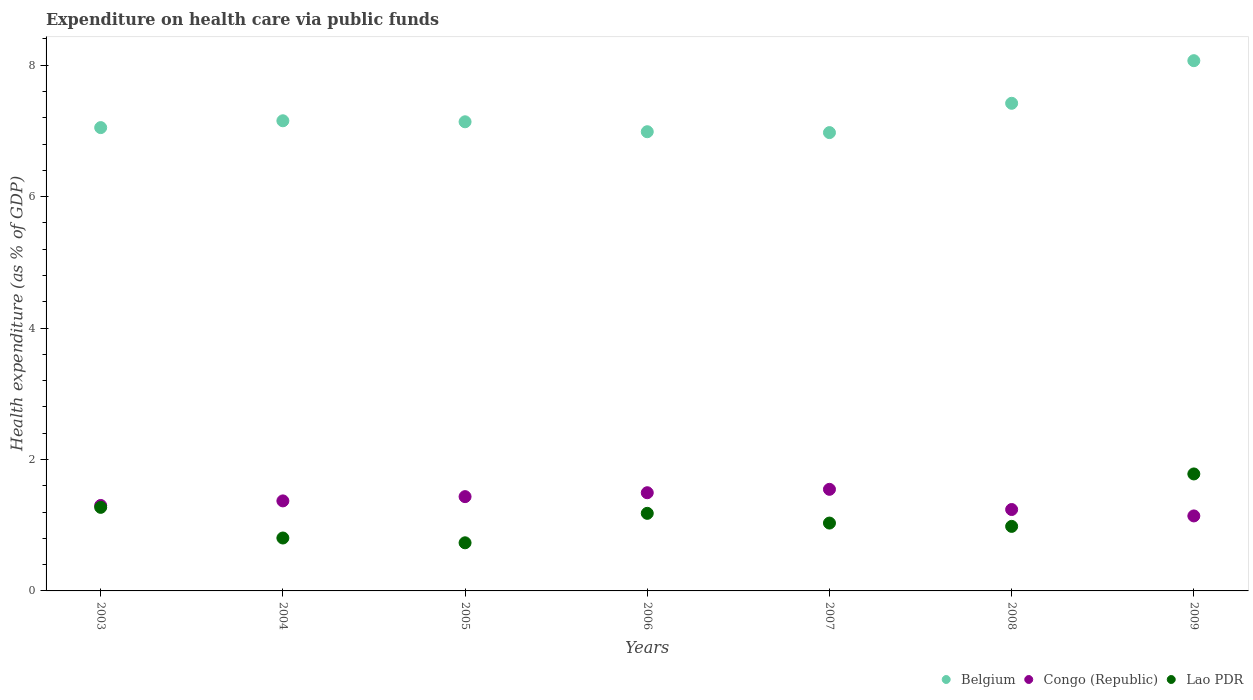How many different coloured dotlines are there?
Give a very brief answer. 3. Is the number of dotlines equal to the number of legend labels?
Your answer should be compact. Yes. What is the expenditure made on health care in Belgium in 2004?
Provide a succinct answer. 7.15. Across all years, what is the maximum expenditure made on health care in Congo (Republic)?
Your answer should be very brief. 1.55. Across all years, what is the minimum expenditure made on health care in Congo (Republic)?
Offer a terse response. 1.14. What is the total expenditure made on health care in Lao PDR in the graph?
Your answer should be compact. 7.78. What is the difference between the expenditure made on health care in Belgium in 2004 and that in 2008?
Offer a very short reply. -0.27. What is the difference between the expenditure made on health care in Congo (Republic) in 2004 and the expenditure made on health care in Lao PDR in 2005?
Offer a very short reply. 0.64. What is the average expenditure made on health care in Lao PDR per year?
Ensure brevity in your answer.  1.11. In the year 2008, what is the difference between the expenditure made on health care in Belgium and expenditure made on health care in Lao PDR?
Provide a short and direct response. 6.44. What is the ratio of the expenditure made on health care in Belgium in 2003 to that in 2006?
Offer a very short reply. 1.01. Is the difference between the expenditure made on health care in Belgium in 2005 and 2009 greater than the difference between the expenditure made on health care in Lao PDR in 2005 and 2009?
Ensure brevity in your answer.  Yes. What is the difference between the highest and the second highest expenditure made on health care in Congo (Republic)?
Ensure brevity in your answer.  0.05. What is the difference between the highest and the lowest expenditure made on health care in Lao PDR?
Provide a succinct answer. 1.05. In how many years, is the expenditure made on health care in Belgium greater than the average expenditure made on health care in Belgium taken over all years?
Provide a succinct answer. 2. Is the sum of the expenditure made on health care in Belgium in 2004 and 2009 greater than the maximum expenditure made on health care in Congo (Republic) across all years?
Ensure brevity in your answer.  Yes. Does the expenditure made on health care in Belgium monotonically increase over the years?
Keep it short and to the point. No. Is the expenditure made on health care in Lao PDR strictly greater than the expenditure made on health care in Belgium over the years?
Your answer should be very brief. No. How many years are there in the graph?
Your response must be concise. 7. What is the difference between two consecutive major ticks on the Y-axis?
Make the answer very short. 2. Where does the legend appear in the graph?
Provide a succinct answer. Bottom right. What is the title of the graph?
Your response must be concise. Expenditure on health care via public funds. What is the label or title of the Y-axis?
Your response must be concise. Health expenditure (as % of GDP). What is the Health expenditure (as % of GDP) in Belgium in 2003?
Ensure brevity in your answer.  7.05. What is the Health expenditure (as % of GDP) in Congo (Republic) in 2003?
Make the answer very short. 1.3. What is the Health expenditure (as % of GDP) of Lao PDR in 2003?
Give a very brief answer. 1.27. What is the Health expenditure (as % of GDP) of Belgium in 2004?
Your answer should be very brief. 7.15. What is the Health expenditure (as % of GDP) in Congo (Republic) in 2004?
Keep it short and to the point. 1.37. What is the Health expenditure (as % of GDP) of Lao PDR in 2004?
Ensure brevity in your answer.  0.81. What is the Health expenditure (as % of GDP) in Belgium in 2005?
Offer a terse response. 7.14. What is the Health expenditure (as % of GDP) of Congo (Republic) in 2005?
Offer a very short reply. 1.43. What is the Health expenditure (as % of GDP) in Lao PDR in 2005?
Offer a terse response. 0.73. What is the Health expenditure (as % of GDP) of Belgium in 2006?
Make the answer very short. 6.99. What is the Health expenditure (as % of GDP) of Congo (Republic) in 2006?
Provide a succinct answer. 1.49. What is the Health expenditure (as % of GDP) in Lao PDR in 2006?
Your response must be concise. 1.18. What is the Health expenditure (as % of GDP) in Belgium in 2007?
Make the answer very short. 6.97. What is the Health expenditure (as % of GDP) in Congo (Republic) in 2007?
Provide a short and direct response. 1.55. What is the Health expenditure (as % of GDP) of Lao PDR in 2007?
Offer a very short reply. 1.03. What is the Health expenditure (as % of GDP) of Belgium in 2008?
Make the answer very short. 7.42. What is the Health expenditure (as % of GDP) of Congo (Republic) in 2008?
Ensure brevity in your answer.  1.24. What is the Health expenditure (as % of GDP) in Lao PDR in 2008?
Your response must be concise. 0.98. What is the Health expenditure (as % of GDP) of Belgium in 2009?
Offer a very short reply. 8.07. What is the Health expenditure (as % of GDP) in Congo (Republic) in 2009?
Your response must be concise. 1.14. What is the Health expenditure (as % of GDP) of Lao PDR in 2009?
Provide a succinct answer. 1.78. Across all years, what is the maximum Health expenditure (as % of GDP) in Belgium?
Your answer should be compact. 8.07. Across all years, what is the maximum Health expenditure (as % of GDP) of Congo (Republic)?
Your response must be concise. 1.55. Across all years, what is the maximum Health expenditure (as % of GDP) of Lao PDR?
Make the answer very short. 1.78. Across all years, what is the minimum Health expenditure (as % of GDP) of Belgium?
Ensure brevity in your answer.  6.97. Across all years, what is the minimum Health expenditure (as % of GDP) in Congo (Republic)?
Provide a succinct answer. 1.14. Across all years, what is the minimum Health expenditure (as % of GDP) in Lao PDR?
Keep it short and to the point. 0.73. What is the total Health expenditure (as % of GDP) of Belgium in the graph?
Offer a terse response. 50.79. What is the total Health expenditure (as % of GDP) in Congo (Republic) in the graph?
Keep it short and to the point. 9.52. What is the total Health expenditure (as % of GDP) in Lao PDR in the graph?
Offer a terse response. 7.78. What is the difference between the Health expenditure (as % of GDP) of Belgium in 2003 and that in 2004?
Offer a terse response. -0.1. What is the difference between the Health expenditure (as % of GDP) in Congo (Republic) in 2003 and that in 2004?
Ensure brevity in your answer.  -0.07. What is the difference between the Health expenditure (as % of GDP) of Lao PDR in 2003 and that in 2004?
Make the answer very short. 0.47. What is the difference between the Health expenditure (as % of GDP) in Belgium in 2003 and that in 2005?
Your response must be concise. -0.09. What is the difference between the Health expenditure (as % of GDP) in Congo (Republic) in 2003 and that in 2005?
Provide a succinct answer. -0.13. What is the difference between the Health expenditure (as % of GDP) of Lao PDR in 2003 and that in 2005?
Give a very brief answer. 0.54. What is the difference between the Health expenditure (as % of GDP) in Belgium in 2003 and that in 2006?
Keep it short and to the point. 0.06. What is the difference between the Health expenditure (as % of GDP) in Congo (Republic) in 2003 and that in 2006?
Provide a short and direct response. -0.19. What is the difference between the Health expenditure (as % of GDP) in Lao PDR in 2003 and that in 2006?
Make the answer very short. 0.09. What is the difference between the Health expenditure (as % of GDP) of Belgium in 2003 and that in 2007?
Make the answer very short. 0.08. What is the difference between the Health expenditure (as % of GDP) of Congo (Republic) in 2003 and that in 2007?
Ensure brevity in your answer.  -0.25. What is the difference between the Health expenditure (as % of GDP) of Lao PDR in 2003 and that in 2007?
Give a very brief answer. 0.24. What is the difference between the Health expenditure (as % of GDP) in Belgium in 2003 and that in 2008?
Provide a succinct answer. -0.37. What is the difference between the Health expenditure (as % of GDP) of Congo (Republic) in 2003 and that in 2008?
Your answer should be compact. 0.06. What is the difference between the Health expenditure (as % of GDP) in Lao PDR in 2003 and that in 2008?
Your answer should be compact. 0.29. What is the difference between the Health expenditure (as % of GDP) of Belgium in 2003 and that in 2009?
Your answer should be compact. -1.02. What is the difference between the Health expenditure (as % of GDP) in Congo (Republic) in 2003 and that in 2009?
Keep it short and to the point. 0.16. What is the difference between the Health expenditure (as % of GDP) of Lao PDR in 2003 and that in 2009?
Provide a short and direct response. -0.51. What is the difference between the Health expenditure (as % of GDP) in Belgium in 2004 and that in 2005?
Your answer should be very brief. 0.02. What is the difference between the Health expenditure (as % of GDP) of Congo (Republic) in 2004 and that in 2005?
Your answer should be compact. -0.06. What is the difference between the Health expenditure (as % of GDP) in Lao PDR in 2004 and that in 2005?
Keep it short and to the point. 0.07. What is the difference between the Health expenditure (as % of GDP) of Belgium in 2004 and that in 2006?
Offer a terse response. 0.17. What is the difference between the Health expenditure (as % of GDP) of Congo (Republic) in 2004 and that in 2006?
Your answer should be compact. -0.12. What is the difference between the Health expenditure (as % of GDP) of Lao PDR in 2004 and that in 2006?
Give a very brief answer. -0.38. What is the difference between the Health expenditure (as % of GDP) of Belgium in 2004 and that in 2007?
Make the answer very short. 0.18. What is the difference between the Health expenditure (as % of GDP) of Congo (Republic) in 2004 and that in 2007?
Your answer should be very brief. -0.18. What is the difference between the Health expenditure (as % of GDP) of Lao PDR in 2004 and that in 2007?
Provide a succinct answer. -0.23. What is the difference between the Health expenditure (as % of GDP) in Belgium in 2004 and that in 2008?
Ensure brevity in your answer.  -0.27. What is the difference between the Health expenditure (as % of GDP) of Congo (Republic) in 2004 and that in 2008?
Provide a succinct answer. 0.13. What is the difference between the Health expenditure (as % of GDP) in Lao PDR in 2004 and that in 2008?
Make the answer very short. -0.18. What is the difference between the Health expenditure (as % of GDP) in Belgium in 2004 and that in 2009?
Provide a succinct answer. -0.91. What is the difference between the Health expenditure (as % of GDP) in Congo (Republic) in 2004 and that in 2009?
Give a very brief answer. 0.23. What is the difference between the Health expenditure (as % of GDP) of Lao PDR in 2004 and that in 2009?
Your answer should be compact. -0.97. What is the difference between the Health expenditure (as % of GDP) in Belgium in 2005 and that in 2006?
Offer a terse response. 0.15. What is the difference between the Health expenditure (as % of GDP) of Congo (Republic) in 2005 and that in 2006?
Your answer should be very brief. -0.06. What is the difference between the Health expenditure (as % of GDP) of Lao PDR in 2005 and that in 2006?
Offer a terse response. -0.45. What is the difference between the Health expenditure (as % of GDP) of Belgium in 2005 and that in 2007?
Provide a short and direct response. 0.16. What is the difference between the Health expenditure (as % of GDP) in Congo (Republic) in 2005 and that in 2007?
Provide a succinct answer. -0.11. What is the difference between the Health expenditure (as % of GDP) in Lao PDR in 2005 and that in 2007?
Give a very brief answer. -0.3. What is the difference between the Health expenditure (as % of GDP) in Belgium in 2005 and that in 2008?
Offer a very short reply. -0.28. What is the difference between the Health expenditure (as % of GDP) in Congo (Republic) in 2005 and that in 2008?
Ensure brevity in your answer.  0.2. What is the difference between the Health expenditure (as % of GDP) of Lao PDR in 2005 and that in 2008?
Your answer should be compact. -0.25. What is the difference between the Health expenditure (as % of GDP) in Belgium in 2005 and that in 2009?
Your answer should be compact. -0.93. What is the difference between the Health expenditure (as % of GDP) of Congo (Republic) in 2005 and that in 2009?
Make the answer very short. 0.29. What is the difference between the Health expenditure (as % of GDP) in Lao PDR in 2005 and that in 2009?
Make the answer very short. -1.05. What is the difference between the Health expenditure (as % of GDP) in Belgium in 2006 and that in 2007?
Ensure brevity in your answer.  0.01. What is the difference between the Health expenditure (as % of GDP) of Congo (Republic) in 2006 and that in 2007?
Offer a very short reply. -0.05. What is the difference between the Health expenditure (as % of GDP) of Lao PDR in 2006 and that in 2007?
Your response must be concise. 0.15. What is the difference between the Health expenditure (as % of GDP) of Belgium in 2006 and that in 2008?
Your answer should be very brief. -0.43. What is the difference between the Health expenditure (as % of GDP) in Congo (Republic) in 2006 and that in 2008?
Offer a very short reply. 0.26. What is the difference between the Health expenditure (as % of GDP) of Lao PDR in 2006 and that in 2008?
Make the answer very short. 0.2. What is the difference between the Health expenditure (as % of GDP) in Belgium in 2006 and that in 2009?
Keep it short and to the point. -1.08. What is the difference between the Health expenditure (as % of GDP) in Congo (Republic) in 2006 and that in 2009?
Give a very brief answer. 0.35. What is the difference between the Health expenditure (as % of GDP) in Lao PDR in 2006 and that in 2009?
Give a very brief answer. -0.6. What is the difference between the Health expenditure (as % of GDP) of Belgium in 2007 and that in 2008?
Your answer should be very brief. -0.45. What is the difference between the Health expenditure (as % of GDP) in Congo (Republic) in 2007 and that in 2008?
Your answer should be compact. 0.31. What is the difference between the Health expenditure (as % of GDP) of Lao PDR in 2007 and that in 2008?
Provide a short and direct response. 0.05. What is the difference between the Health expenditure (as % of GDP) in Belgium in 2007 and that in 2009?
Your response must be concise. -1.09. What is the difference between the Health expenditure (as % of GDP) in Congo (Republic) in 2007 and that in 2009?
Provide a short and direct response. 0.4. What is the difference between the Health expenditure (as % of GDP) of Lao PDR in 2007 and that in 2009?
Your answer should be very brief. -0.75. What is the difference between the Health expenditure (as % of GDP) of Belgium in 2008 and that in 2009?
Provide a short and direct response. -0.65. What is the difference between the Health expenditure (as % of GDP) in Congo (Republic) in 2008 and that in 2009?
Keep it short and to the point. 0.1. What is the difference between the Health expenditure (as % of GDP) in Lao PDR in 2008 and that in 2009?
Give a very brief answer. -0.8. What is the difference between the Health expenditure (as % of GDP) of Belgium in 2003 and the Health expenditure (as % of GDP) of Congo (Republic) in 2004?
Provide a succinct answer. 5.68. What is the difference between the Health expenditure (as % of GDP) of Belgium in 2003 and the Health expenditure (as % of GDP) of Lao PDR in 2004?
Provide a succinct answer. 6.24. What is the difference between the Health expenditure (as % of GDP) in Congo (Republic) in 2003 and the Health expenditure (as % of GDP) in Lao PDR in 2004?
Make the answer very short. 0.49. What is the difference between the Health expenditure (as % of GDP) of Belgium in 2003 and the Health expenditure (as % of GDP) of Congo (Republic) in 2005?
Offer a very short reply. 5.62. What is the difference between the Health expenditure (as % of GDP) in Belgium in 2003 and the Health expenditure (as % of GDP) in Lao PDR in 2005?
Your answer should be very brief. 6.32. What is the difference between the Health expenditure (as % of GDP) of Congo (Republic) in 2003 and the Health expenditure (as % of GDP) of Lao PDR in 2005?
Provide a succinct answer. 0.57. What is the difference between the Health expenditure (as % of GDP) of Belgium in 2003 and the Health expenditure (as % of GDP) of Congo (Republic) in 2006?
Offer a terse response. 5.56. What is the difference between the Health expenditure (as % of GDP) in Belgium in 2003 and the Health expenditure (as % of GDP) in Lao PDR in 2006?
Provide a short and direct response. 5.87. What is the difference between the Health expenditure (as % of GDP) of Congo (Republic) in 2003 and the Health expenditure (as % of GDP) of Lao PDR in 2006?
Your response must be concise. 0.12. What is the difference between the Health expenditure (as % of GDP) of Belgium in 2003 and the Health expenditure (as % of GDP) of Congo (Republic) in 2007?
Make the answer very short. 5.5. What is the difference between the Health expenditure (as % of GDP) in Belgium in 2003 and the Health expenditure (as % of GDP) in Lao PDR in 2007?
Offer a very short reply. 6.02. What is the difference between the Health expenditure (as % of GDP) of Congo (Republic) in 2003 and the Health expenditure (as % of GDP) of Lao PDR in 2007?
Give a very brief answer. 0.27. What is the difference between the Health expenditure (as % of GDP) in Belgium in 2003 and the Health expenditure (as % of GDP) in Congo (Republic) in 2008?
Keep it short and to the point. 5.81. What is the difference between the Health expenditure (as % of GDP) in Belgium in 2003 and the Health expenditure (as % of GDP) in Lao PDR in 2008?
Give a very brief answer. 6.07. What is the difference between the Health expenditure (as % of GDP) in Congo (Republic) in 2003 and the Health expenditure (as % of GDP) in Lao PDR in 2008?
Your answer should be very brief. 0.32. What is the difference between the Health expenditure (as % of GDP) in Belgium in 2003 and the Health expenditure (as % of GDP) in Congo (Republic) in 2009?
Give a very brief answer. 5.91. What is the difference between the Health expenditure (as % of GDP) in Belgium in 2003 and the Health expenditure (as % of GDP) in Lao PDR in 2009?
Offer a terse response. 5.27. What is the difference between the Health expenditure (as % of GDP) in Congo (Republic) in 2003 and the Health expenditure (as % of GDP) in Lao PDR in 2009?
Offer a terse response. -0.48. What is the difference between the Health expenditure (as % of GDP) in Belgium in 2004 and the Health expenditure (as % of GDP) in Congo (Republic) in 2005?
Offer a terse response. 5.72. What is the difference between the Health expenditure (as % of GDP) of Belgium in 2004 and the Health expenditure (as % of GDP) of Lao PDR in 2005?
Make the answer very short. 6.42. What is the difference between the Health expenditure (as % of GDP) of Congo (Republic) in 2004 and the Health expenditure (as % of GDP) of Lao PDR in 2005?
Offer a terse response. 0.64. What is the difference between the Health expenditure (as % of GDP) in Belgium in 2004 and the Health expenditure (as % of GDP) in Congo (Republic) in 2006?
Offer a terse response. 5.66. What is the difference between the Health expenditure (as % of GDP) of Belgium in 2004 and the Health expenditure (as % of GDP) of Lao PDR in 2006?
Keep it short and to the point. 5.97. What is the difference between the Health expenditure (as % of GDP) in Congo (Republic) in 2004 and the Health expenditure (as % of GDP) in Lao PDR in 2006?
Provide a succinct answer. 0.19. What is the difference between the Health expenditure (as % of GDP) of Belgium in 2004 and the Health expenditure (as % of GDP) of Congo (Republic) in 2007?
Your answer should be very brief. 5.61. What is the difference between the Health expenditure (as % of GDP) in Belgium in 2004 and the Health expenditure (as % of GDP) in Lao PDR in 2007?
Make the answer very short. 6.12. What is the difference between the Health expenditure (as % of GDP) of Congo (Republic) in 2004 and the Health expenditure (as % of GDP) of Lao PDR in 2007?
Your answer should be very brief. 0.34. What is the difference between the Health expenditure (as % of GDP) in Belgium in 2004 and the Health expenditure (as % of GDP) in Congo (Republic) in 2008?
Make the answer very short. 5.91. What is the difference between the Health expenditure (as % of GDP) of Belgium in 2004 and the Health expenditure (as % of GDP) of Lao PDR in 2008?
Make the answer very short. 6.17. What is the difference between the Health expenditure (as % of GDP) of Congo (Republic) in 2004 and the Health expenditure (as % of GDP) of Lao PDR in 2008?
Offer a very short reply. 0.39. What is the difference between the Health expenditure (as % of GDP) of Belgium in 2004 and the Health expenditure (as % of GDP) of Congo (Republic) in 2009?
Provide a short and direct response. 6.01. What is the difference between the Health expenditure (as % of GDP) in Belgium in 2004 and the Health expenditure (as % of GDP) in Lao PDR in 2009?
Keep it short and to the point. 5.37. What is the difference between the Health expenditure (as % of GDP) of Congo (Republic) in 2004 and the Health expenditure (as % of GDP) of Lao PDR in 2009?
Your response must be concise. -0.41. What is the difference between the Health expenditure (as % of GDP) in Belgium in 2005 and the Health expenditure (as % of GDP) in Congo (Republic) in 2006?
Keep it short and to the point. 5.64. What is the difference between the Health expenditure (as % of GDP) of Belgium in 2005 and the Health expenditure (as % of GDP) of Lao PDR in 2006?
Offer a very short reply. 5.96. What is the difference between the Health expenditure (as % of GDP) in Congo (Republic) in 2005 and the Health expenditure (as % of GDP) in Lao PDR in 2006?
Your answer should be compact. 0.25. What is the difference between the Health expenditure (as % of GDP) in Belgium in 2005 and the Health expenditure (as % of GDP) in Congo (Republic) in 2007?
Your answer should be compact. 5.59. What is the difference between the Health expenditure (as % of GDP) in Belgium in 2005 and the Health expenditure (as % of GDP) in Lao PDR in 2007?
Make the answer very short. 6.11. What is the difference between the Health expenditure (as % of GDP) in Congo (Republic) in 2005 and the Health expenditure (as % of GDP) in Lao PDR in 2007?
Offer a terse response. 0.4. What is the difference between the Health expenditure (as % of GDP) in Belgium in 2005 and the Health expenditure (as % of GDP) in Congo (Republic) in 2008?
Ensure brevity in your answer.  5.9. What is the difference between the Health expenditure (as % of GDP) of Belgium in 2005 and the Health expenditure (as % of GDP) of Lao PDR in 2008?
Give a very brief answer. 6.16. What is the difference between the Health expenditure (as % of GDP) in Congo (Republic) in 2005 and the Health expenditure (as % of GDP) in Lao PDR in 2008?
Provide a short and direct response. 0.45. What is the difference between the Health expenditure (as % of GDP) in Belgium in 2005 and the Health expenditure (as % of GDP) in Congo (Republic) in 2009?
Offer a terse response. 6. What is the difference between the Health expenditure (as % of GDP) of Belgium in 2005 and the Health expenditure (as % of GDP) of Lao PDR in 2009?
Provide a succinct answer. 5.36. What is the difference between the Health expenditure (as % of GDP) of Congo (Republic) in 2005 and the Health expenditure (as % of GDP) of Lao PDR in 2009?
Provide a succinct answer. -0.35. What is the difference between the Health expenditure (as % of GDP) in Belgium in 2006 and the Health expenditure (as % of GDP) in Congo (Republic) in 2007?
Make the answer very short. 5.44. What is the difference between the Health expenditure (as % of GDP) in Belgium in 2006 and the Health expenditure (as % of GDP) in Lao PDR in 2007?
Give a very brief answer. 5.95. What is the difference between the Health expenditure (as % of GDP) of Congo (Republic) in 2006 and the Health expenditure (as % of GDP) of Lao PDR in 2007?
Ensure brevity in your answer.  0.46. What is the difference between the Health expenditure (as % of GDP) of Belgium in 2006 and the Health expenditure (as % of GDP) of Congo (Republic) in 2008?
Your answer should be very brief. 5.75. What is the difference between the Health expenditure (as % of GDP) of Belgium in 2006 and the Health expenditure (as % of GDP) of Lao PDR in 2008?
Provide a short and direct response. 6.01. What is the difference between the Health expenditure (as % of GDP) of Congo (Republic) in 2006 and the Health expenditure (as % of GDP) of Lao PDR in 2008?
Your answer should be compact. 0.51. What is the difference between the Health expenditure (as % of GDP) in Belgium in 2006 and the Health expenditure (as % of GDP) in Congo (Republic) in 2009?
Ensure brevity in your answer.  5.85. What is the difference between the Health expenditure (as % of GDP) of Belgium in 2006 and the Health expenditure (as % of GDP) of Lao PDR in 2009?
Give a very brief answer. 5.21. What is the difference between the Health expenditure (as % of GDP) in Congo (Republic) in 2006 and the Health expenditure (as % of GDP) in Lao PDR in 2009?
Give a very brief answer. -0.29. What is the difference between the Health expenditure (as % of GDP) in Belgium in 2007 and the Health expenditure (as % of GDP) in Congo (Republic) in 2008?
Give a very brief answer. 5.73. What is the difference between the Health expenditure (as % of GDP) in Belgium in 2007 and the Health expenditure (as % of GDP) in Lao PDR in 2008?
Provide a succinct answer. 5.99. What is the difference between the Health expenditure (as % of GDP) of Congo (Republic) in 2007 and the Health expenditure (as % of GDP) of Lao PDR in 2008?
Give a very brief answer. 0.56. What is the difference between the Health expenditure (as % of GDP) of Belgium in 2007 and the Health expenditure (as % of GDP) of Congo (Republic) in 2009?
Ensure brevity in your answer.  5.83. What is the difference between the Health expenditure (as % of GDP) in Belgium in 2007 and the Health expenditure (as % of GDP) in Lao PDR in 2009?
Your answer should be compact. 5.19. What is the difference between the Health expenditure (as % of GDP) of Congo (Republic) in 2007 and the Health expenditure (as % of GDP) of Lao PDR in 2009?
Your answer should be very brief. -0.23. What is the difference between the Health expenditure (as % of GDP) in Belgium in 2008 and the Health expenditure (as % of GDP) in Congo (Republic) in 2009?
Your answer should be compact. 6.28. What is the difference between the Health expenditure (as % of GDP) of Belgium in 2008 and the Health expenditure (as % of GDP) of Lao PDR in 2009?
Provide a short and direct response. 5.64. What is the difference between the Health expenditure (as % of GDP) of Congo (Republic) in 2008 and the Health expenditure (as % of GDP) of Lao PDR in 2009?
Give a very brief answer. -0.54. What is the average Health expenditure (as % of GDP) in Belgium per year?
Your answer should be very brief. 7.26. What is the average Health expenditure (as % of GDP) of Congo (Republic) per year?
Provide a short and direct response. 1.36. What is the average Health expenditure (as % of GDP) in Lao PDR per year?
Your response must be concise. 1.11. In the year 2003, what is the difference between the Health expenditure (as % of GDP) in Belgium and Health expenditure (as % of GDP) in Congo (Republic)?
Keep it short and to the point. 5.75. In the year 2003, what is the difference between the Health expenditure (as % of GDP) of Belgium and Health expenditure (as % of GDP) of Lao PDR?
Your response must be concise. 5.78. In the year 2003, what is the difference between the Health expenditure (as % of GDP) of Congo (Republic) and Health expenditure (as % of GDP) of Lao PDR?
Your answer should be very brief. 0.03. In the year 2004, what is the difference between the Health expenditure (as % of GDP) in Belgium and Health expenditure (as % of GDP) in Congo (Republic)?
Provide a succinct answer. 5.78. In the year 2004, what is the difference between the Health expenditure (as % of GDP) in Belgium and Health expenditure (as % of GDP) in Lao PDR?
Provide a short and direct response. 6.35. In the year 2004, what is the difference between the Health expenditure (as % of GDP) of Congo (Republic) and Health expenditure (as % of GDP) of Lao PDR?
Ensure brevity in your answer.  0.56. In the year 2005, what is the difference between the Health expenditure (as % of GDP) of Belgium and Health expenditure (as % of GDP) of Congo (Republic)?
Give a very brief answer. 5.7. In the year 2005, what is the difference between the Health expenditure (as % of GDP) of Belgium and Health expenditure (as % of GDP) of Lao PDR?
Make the answer very short. 6.41. In the year 2005, what is the difference between the Health expenditure (as % of GDP) in Congo (Republic) and Health expenditure (as % of GDP) in Lao PDR?
Your answer should be compact. 0.7. In the year 2006, what is the difference between the Health expenditure (as % of GDP) of Belgium and Health expenditure (as % of GDP) of Congo (Republic)?
Provide a succinct answer. 5.49. In the year 2006, what is the difference between the Health expenditure (as % of GDP) in Belgium and Health expenditure (as % of GDP) in Lao PDR?
Provide a short and direct response. 5.81. In the year 2006, what is the difference between the Health expenditure (as % of GDP) in Congo (Republic) and Health expenditure (as % of GDP) in Lao PDR?
Provide a short and direct response. 0.31. In the year 2007, what is the difference between the Health expenditure (as % of GDP) in Belgium and Health expenditure (as % of GDP) in Congo (Republic)?
Ensure brevity in your answer.  5.43. In the year 2007, what is the difference between the Health expenditure (as % of GDP) in Belgium and Health expenditure (as % of GDP) in Lao PDR?
Your response must be concise. 5.94. In the year 2007, what is the difference between the Health expenditure (as % of GDP) in Congo (Republic) and Health expenditure (as % of GDP) in Lao PDR?
Provide a succinct answer. 0.51. In the year 2008, what is the difference between the Health expenditure (as % of GDP) of Belgium and Health expenditure (as % of GDP) of Congo (Republic)?
Your answer should be very brief. 6.18. In the year 2008, what is the difference between the Health expenditure (as % of GDP) in Belgium and Health expenditure (as % of GDP) in Lao PDR?
Your answer should be compact. 6.44. In the year 2008, what is the difference between the Health expenditure (as % of GDP) in Congo (Republic) and Health expenditure (as % of GDP) in Lao PDR?
Ensure brevity in your answer.  0.26. In the year 2009, what is the difference between the Health expenditure (as % of GDP) of Belgium and Health expenditure (as % of GDP) of Congo (Republic)?
Your answer should be very brief. 6.93. In the year 2009, what is the difference between the Health expenditure (as % of GDP) of Belgium and Health expenditure (as % of GDP) of Lao PDR?
Keep it short and to the point. 6.29. In the year 2009, what is the difference between the Health expenditure (as % of GDP) of Congo (Republic) and Health expenditure (as % of GDP) of Lao PDR?
Ensure brevity in your answer.  -0.64. What is the ratio of the Health expenditure (as % of GDP) of Belgium in 2003 to that in 2004?
Provide a succinct answer. 0.99. What is the ratio of the Health expenditure (as % of GDP) in Congo (Republic) in 2003 to that in 2004?
Your answer should be compact. 0.95. What is the ratio of the Health expenditure (as % of GDP) in Lao PDR in 2003 to that in 2004?
Your response must be concise. 1.58. What is the ratio of the Health expenditure (as % of GDP) in Belgium in 2003 to that in 2005?
Offer a very short reply. 0.99. What is the ratio of the Health expenditure (as % of GDP) in Congo (Republic) in 2003 to that in 2005?
Your answer should be compact. 0.91. What is the ratio of the Health expenditure (as % of GDP) of Lao PDR in 2003 to that in 2005?
Ensure brevity in your answer.  1.74. What is the ratio of the Health expenditure (as % of GDP) of Congo (Republic) in 2003 to that in 2006?
Your response must be concise. 0.87. What is the ratio of the Health expenditure (as % of GDP) of Lao PDR in 2003 to that in 2006?
Your answer should be compact. 1.08. What is the ratio of the Health expenditure (as % of GDP) in Belgium in 2003 to that in 2007?
Your answer should be compact. 1.01. What is the ratio of the Health expenditure (as % of GDP) in Congo (Republic) in 2003 to that in 2007?
Offer a very short reply. 0.84. What is the ratio of the Health expenditure (as % of GDP) of Lao PDR in 2003 to that in 2007?
Offer a terse response. 1.23. What is the ratio of the Health expenditure (as % of GDP) of Belgium in 2003 to that in 2008?
Offer a terse response. 0.95. What is the ratio of the Health expenditure (as % of GDP) of Congo (Republic) in 2003 to that in 2008?
Give a very brief answer. 1.05. What is the ratio of the Health expenditure (as % of GDP) in Lao PDR in 2003 to that in 2008?
Your answer should be very brief. 1.29. What is the ratio of the Health expenditure (as % of GDP) in Belgium in 2003 to that in 2009?
Offer a very short reply. 0.87. What is the ratio of the Health expenditure (as % of GDP) of Congo (Republic) in 2003 to that in 2009?
Provide a short and direct response. 1.14. What is the ratio of the Health expenditure (as % of GDP) in Lao PDR in 2003 to that in 2009?
Your answer should be very brief. 0.71. What is the ratio of the Health expenditure (as % of GDP) in Congo (Republic) in 2004 to that in 2005?
Offer a terse response. 0.95. What is the ratio of the Health expenditure (as % of GDP) of Lao PDR in 2004 to that in 2005?
Your response must be concise. 1.1. What is the ratio of the Health expenditure (as % of GDP) of Belgium in 2004 to that in 2006?
Provide a short and direct response. 1.02. What is the ratio of the Health expenditure (as % of GDP) in Congo (Republic) in 2004 to that in 2006?
Ensure brevity in your answer.  0.92. What is the ratio of the Health expenditure (as % of GDP) of Lao PDR in 2004 to that in 2006?
Your answer should be compact. 0.68. What is the ratio of the Health expenditure (as % of GDP) of Belgium in 2004 to that in 2007?
Make the answer very short. 1.03. What is the ratio of the Health expenditure (as % of GDP) of Congo (Republic) in 2004 to that in 2007?
Provide a succinct answer. 0.89. What is the ratio of the Health expenditure (as % of GDP) of Lao PDR in 2004 to that in 2007?
Your response must be concise. 0.78. What is the ratio of the Health expenditure (as % of GDP) of Belgium in 2004 to that in 2008?
Your answer should be compact. 0.96. What is the ratio of the Health expenditure (as % of GDP) of Congo (Republic) in 2004 to that in 2008?
Offer a terse response. 1.11. What is the ratio of the Health expenditure (as % of GDP) in Lao PDR in 2004 to that in 2008?
Ensure brevity in your answer.  0.82. What is the ratio of the Health expenditure (as % of GDP) of Belgium in 2004 to that in 2009?
Your answer should be compact. 0.89. What is the ratio of the Health expenditure (as % of GDP) in Congo (Republic) in 2004 to that in 2009?
Keep it short and to the point. 1.2. What is the ratio of the Health expenditure (as % of GDP) of Lao PDR in 2004 to that in 2009?
Your response must be concise. 0.45. What is the ratio of the Health expenditure (as % of GDP) of Belgium in 2005 to that in 2006?
Provide a short and direct response. 1.02. What is the ratio of the Health expenditure (as % of GDP) in Congo (Republic) in 2005 to that in 2006?
Give a very brief answer. 0.96. What is the ratio of the Health expenditure (as % of GDP) of Lao PDR in 2005 to that in 2006?
Your answer should be very brief. 0.62. What is the ratio of the Health expenditure (as % of GDP) in Belgium in 2005 to that in 2007?
Provide a short and direct response. 1.02. What is the ratio of the Health expenditure (as % of GDP) in Congo (Republic) in 2005 to that in 2007?
Keep it short and to the point. 0.93. What is the ratio of the Health expenditure (as % of GDP) of Lao PDR in 2005 to that in 2007?
Your response must be concise. 0.71. What is the ratio of the Health expenditure (as % of GDP) of Belgium in 2005 to that in 2008?
Offer a very short reply. 0.96. What is the ratio of the Health expenditure (as % of GDP) in Congo (Republic) in 2005 to that in 2008?
Your answer should be compact. 1.16. What is the ratio of the Health expenditure (as % of GDP) of Lao PDR in 2005 to that in 2008?
Your response must be concise. 0.75. What is the ratio of the Health expenditure (as % of GDP) in Belgium in 2005 to that in 2009?
Provide a short and direct response. 0.88. What is the ratio of the Health expenditure (as % of GDP) in Congo (Republic) in 2005 to that in 2009?
Provide a succinct answer. 1.26. What is the ratio of the Health expenditure (as % of GDP) in Lao PDR in 2005 to that in 2009?
Offer a terse response. 0.41. What is the ratio of the Health expenditure (as % of GDP) in Congo (Republic) in 2006 to that in 2007?
Keep it short and to the point. 0.97. What is the ratio of the Health expenditure (as % of GDP) of Lao PDR in 2006 to that in 2007?
Provide a succinct answer. 1.14. What is the ratio of the Health expenditure (as % of GDP) in Belgium in 2006 to that in 2008?
Offer a very short reply. 0.94. What is the ratio of the Health expenditure (as % of GDP) of Congo (Republic) in 2006 to that in 2008?
Your response must be concise. 1.21. What is the ratio of the Health expenditure (as % of GDP) of Lao PDR in 2006 to that in 2008?
Keep it short and to the point. 1.2. What is the ratio of the Health expenditure (as % of GDP) in Belgium in 2006 to that in 2009?
Provide a succinct answer. 0.87. What is the ratio of the Health expenditure (as % of GDP) of Congo (Republic) in 2006 to that in 2009?
Your answer should be compact. 1.31. What is the ratio of the Health expenditure (as % of GDP) of Lao PDR in 2006 to that in 2009?
Keep it short and to the point. 0.66. What is the ratio of the Health expenditure (as % of GDP) in Belgium in 2007 to that in 2008?
Provide a short and direct response. 0.94. What is the ratio of the Health expenditure (as % of GDP) in Congo (Republic) in 2007 to that in 2008?
Give a very brief answer. 1.25. What is the ratio of the Health expenditure (as % of GDP) of Lao PDR in 2007 to that in 2008?
Provide a short and direct response. 1.05. What is the ratio of the Health expenditure (as % of GDP) in Belgium in 2007 to that in 2009?
Offer a very short reply. 0.86. What is the ratio of the Health expenditure (as % of GDP) in Congo (Republic) in 2007 to that in 2009?
Your answer should be very brief. 1.35. What is the ratio of the Health expenditure (as % of GDP) in Lao PDR in 2007 to that in 2009?
Your response must be concise. 0.58. What is the ratio of the Health expenditure (as % of GDP) in Belgium in 2008 to that in 2009?
Offer a very short reply. 0.92. What is the ratio of the Health expenditure (as % of GDP) of Congo (Republic) in 2008 to that in 2009?
Your response must be concise. 1.09. What is the ratio of the Health expenditure (as % of GDP) of Lao PDR in 2008 to that in 2009?
Make the answer very short. 0.55. What is the difference between the highest and the second highest Health expenditure (as % of GDP) of Belgium?
Give a very brief answer. 0.65. What is the difference between the highest and the second highest Health expenditure (as % of GDP) in Congo (Republic)?
Offer a terse response. 0.05. What is the difference between the highest and the second highest Health expenditure (as % of GDP) in Lao PDR?
Your answer should be very brief. 0.51. What is the difference between the highest and the lowest Health expenditure (as % of GDP) of Belgium?
Your answer should be very brief. 1.09. What is the difference between the highest and the lowest Health expenditure (as % of GDP) of Congo (Republic)?
Make the answer very short. 0.4. What is the difference between the highest and the lowest Health expenditure (as % of GDP) of Lao PDR?
Your response must be concise. 1.05. 